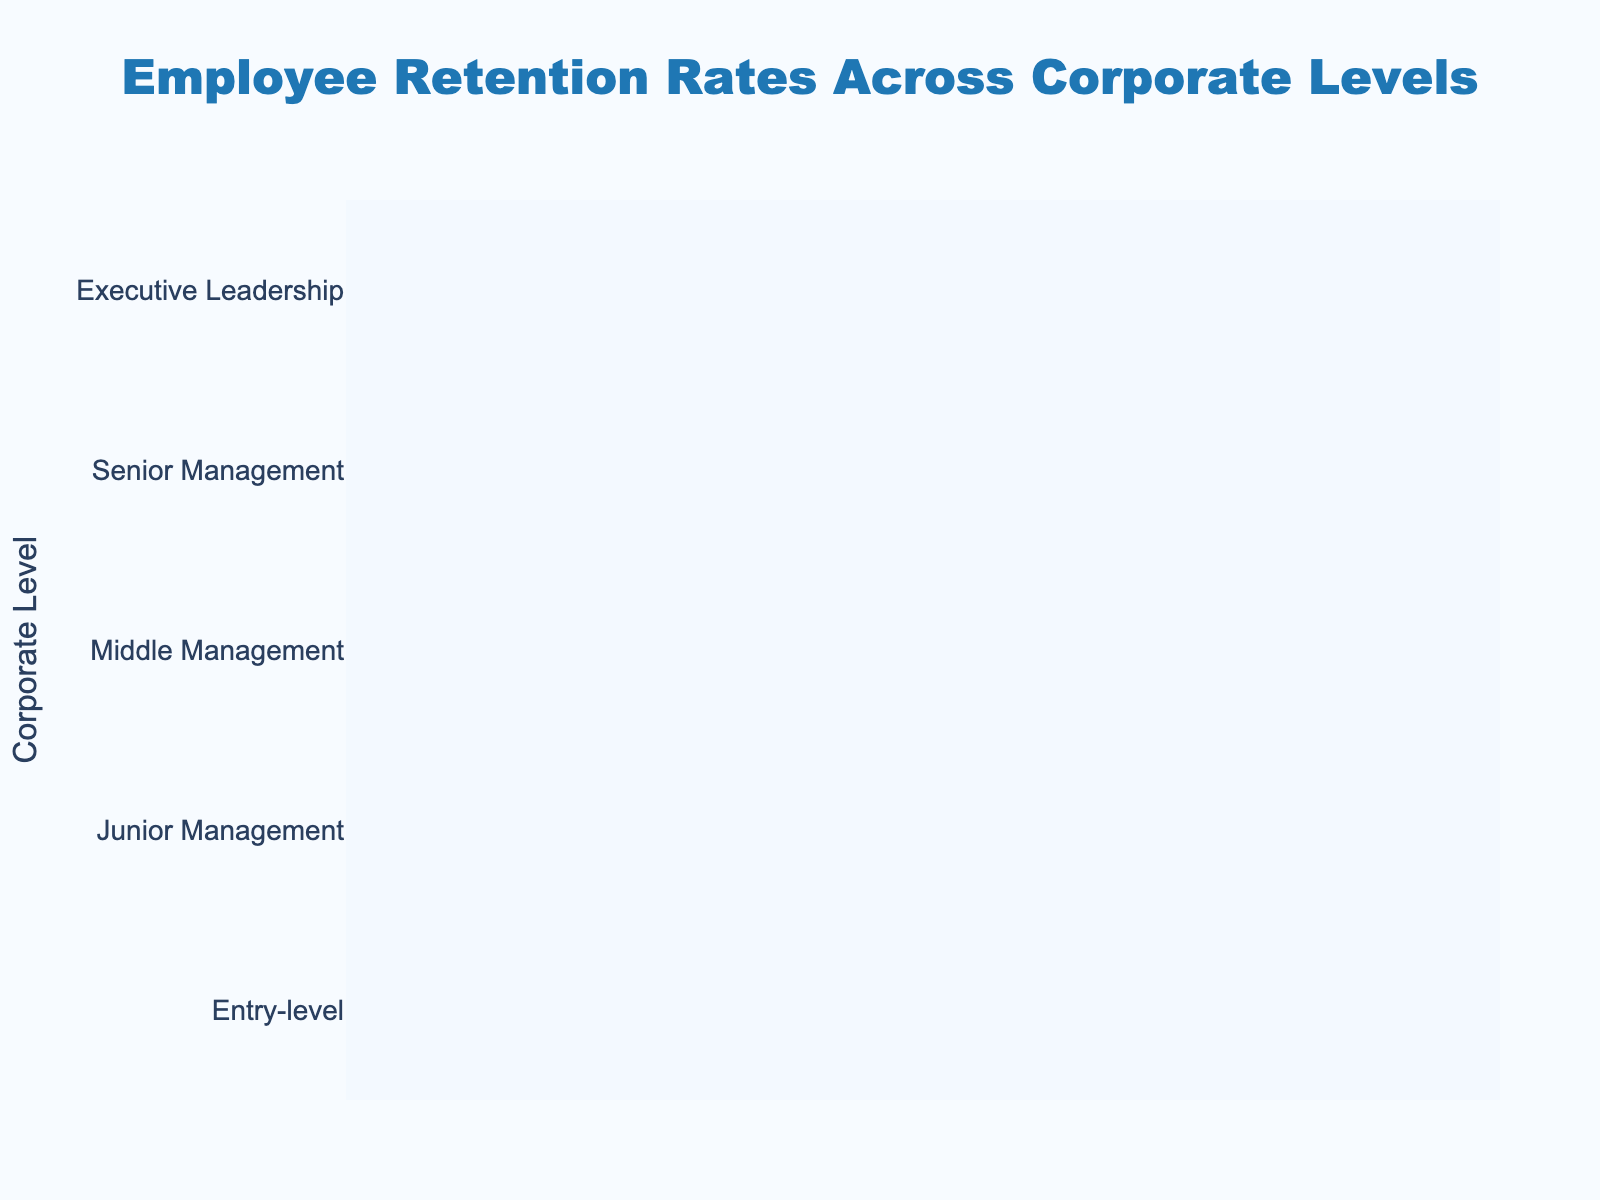What is the retention rate at the entry-level? Look at the funnel chart for the entry-level and read the retention rate mentioned inside the bar.
Answer: 85% What is the lowest retention rate shown in the chart? Find the level with the smallest retention rate from the visual information.
Answer: 62% How many levels are represented in the chart? Count the number of different corporate levels listed on the y-axis.
Answer: 5 Which corporate level has the highest retention rate? Identify the corporate level with the largest portion of the funnel at the top.
Answer: Entry-level What is the difference in retention rate between Junior Management and Middle Management? Subtract the retention rate of Middle Management from that of Junior Management (78 - 72).
Answer: 6% Is the retention rate of Senior Management higher or lower than Executive Leadership? Compare the retention rates shown for Senior Management and Executive Leadership.
Answer: Higher What percentage of the initial retention rate is at the Executive Leadership level compared to the Entry-level? Executive Leadership retention rate is 62%, and Entry-level is 85%. The percentage is calculated as (62/85) * 100.
Answer: 72.94% What trend is observed in the retention rates as you move up the corporate levels? Examine the chart to see if retention rates increase, decrease, or stay the same as you move from entry-level to executive leadership.
Answer: Decrease How much higher is the retention rate at Middle Management compared to Executive Leadership? Subtract the retention rate of Executive Leadership from Middle Management (72 - 62).
Answer: 10% If a company wants to improve overall retention, should they focus more on lower or higher corporate levels based on this chart? Identify where the significant drop in retention rates occurs to decide the focus areas for improvement.
Answer: Higher levels 